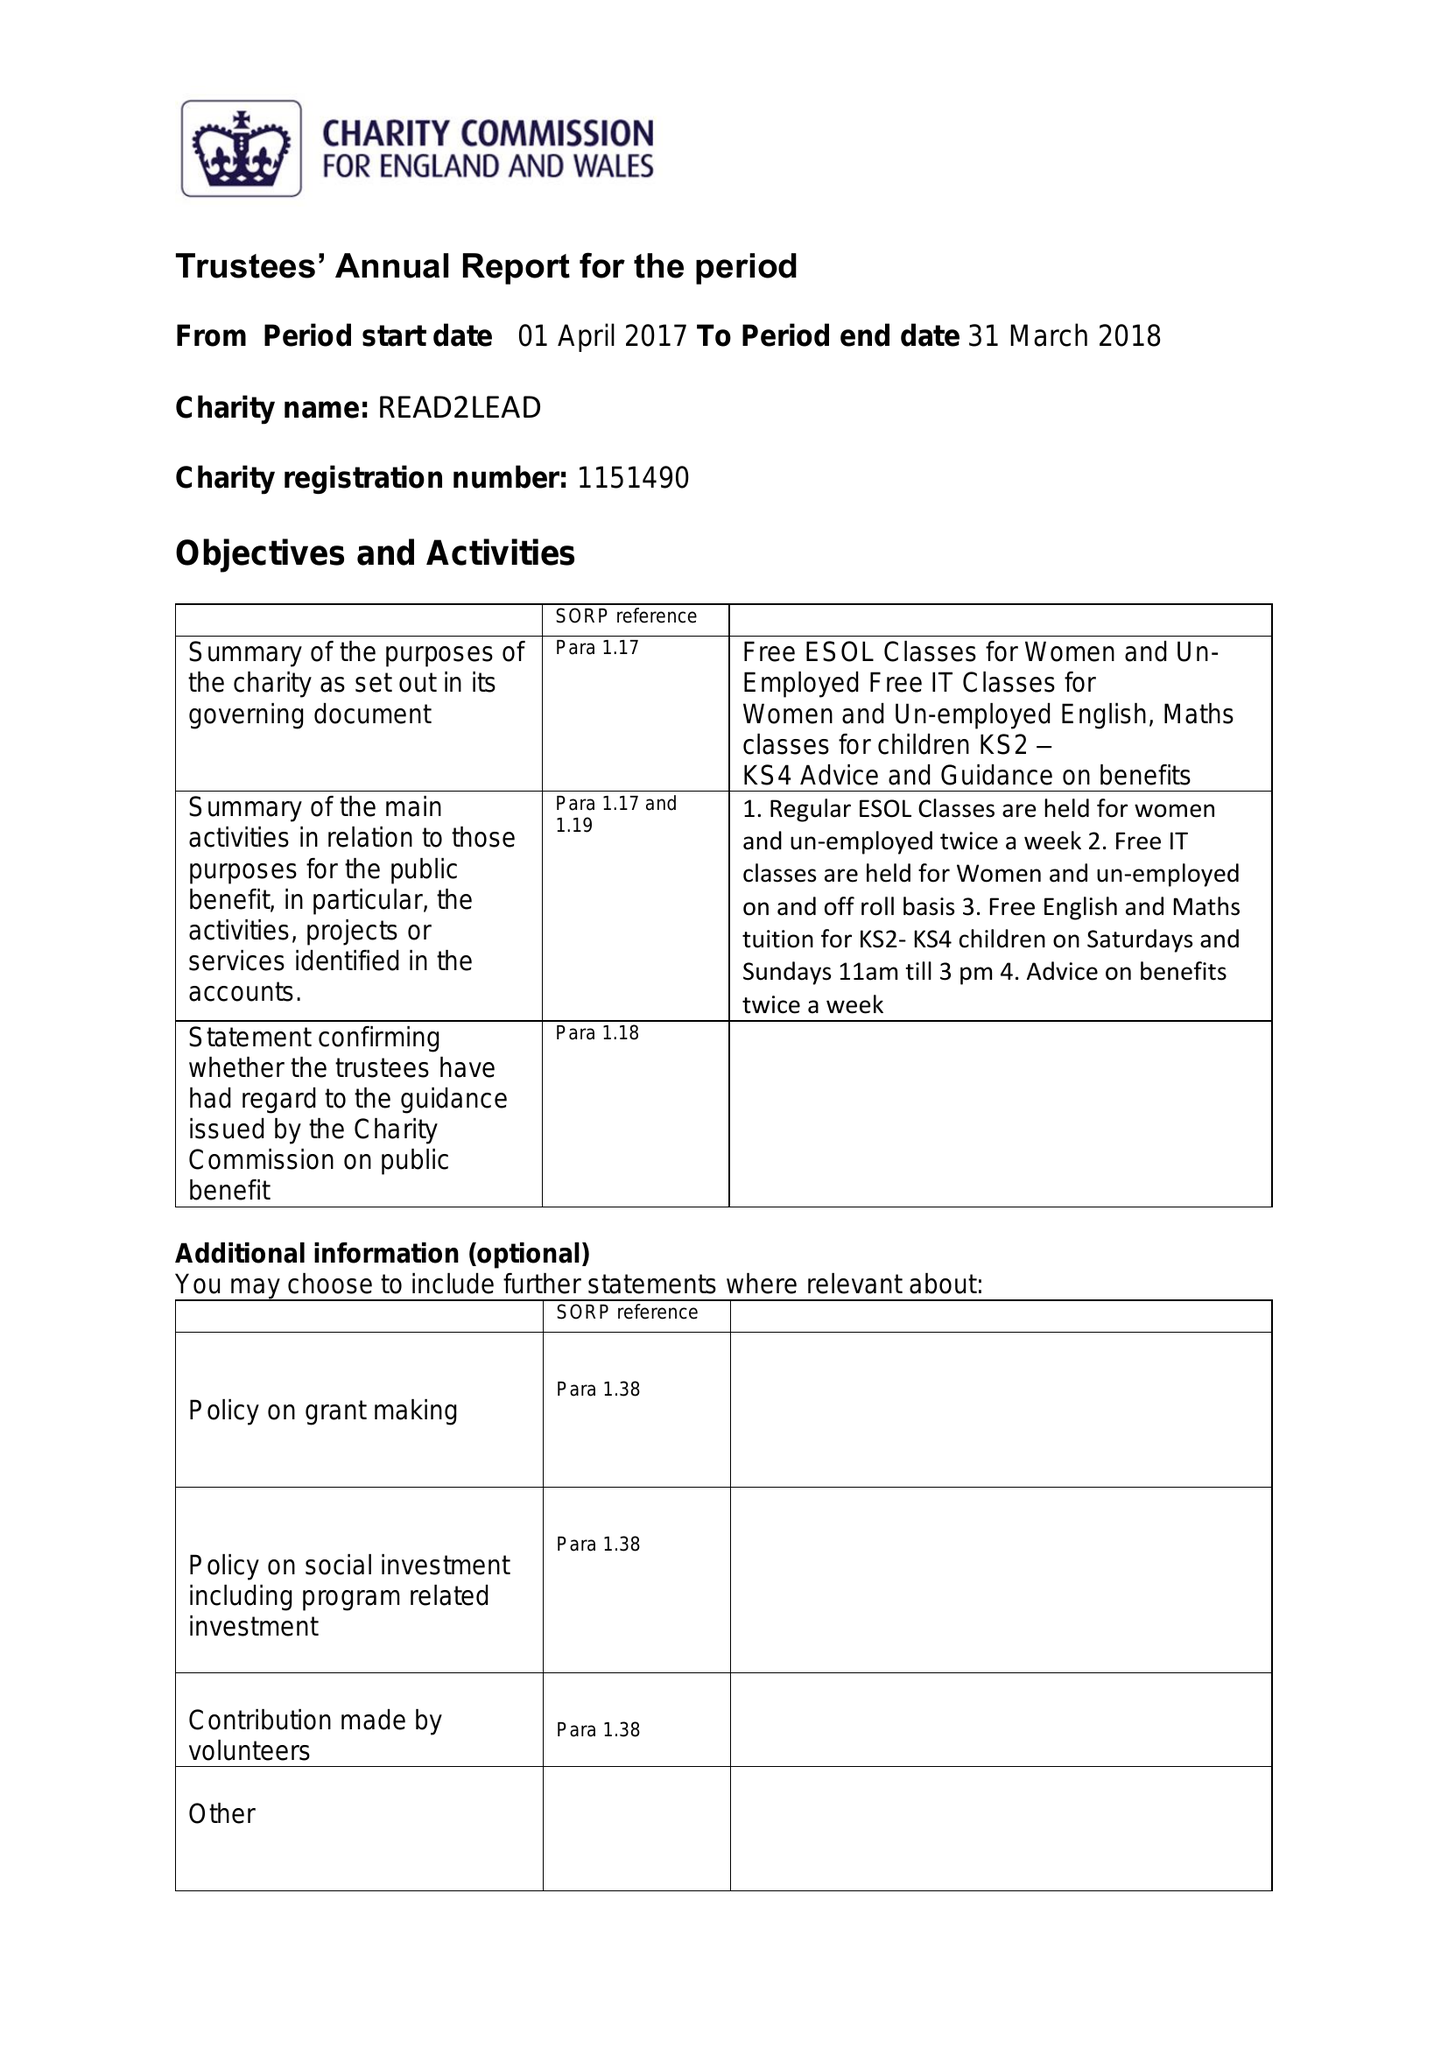What is the value for the report_date?
Answer the question using a single word or phrase. 2018-03-31 